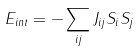<formula> <loc_0><loc_0><loc_500><loc_500>E _ { i n t } = - \sum _ { i j } J _ { i j } S _ { i } S _ { j }</formula> 